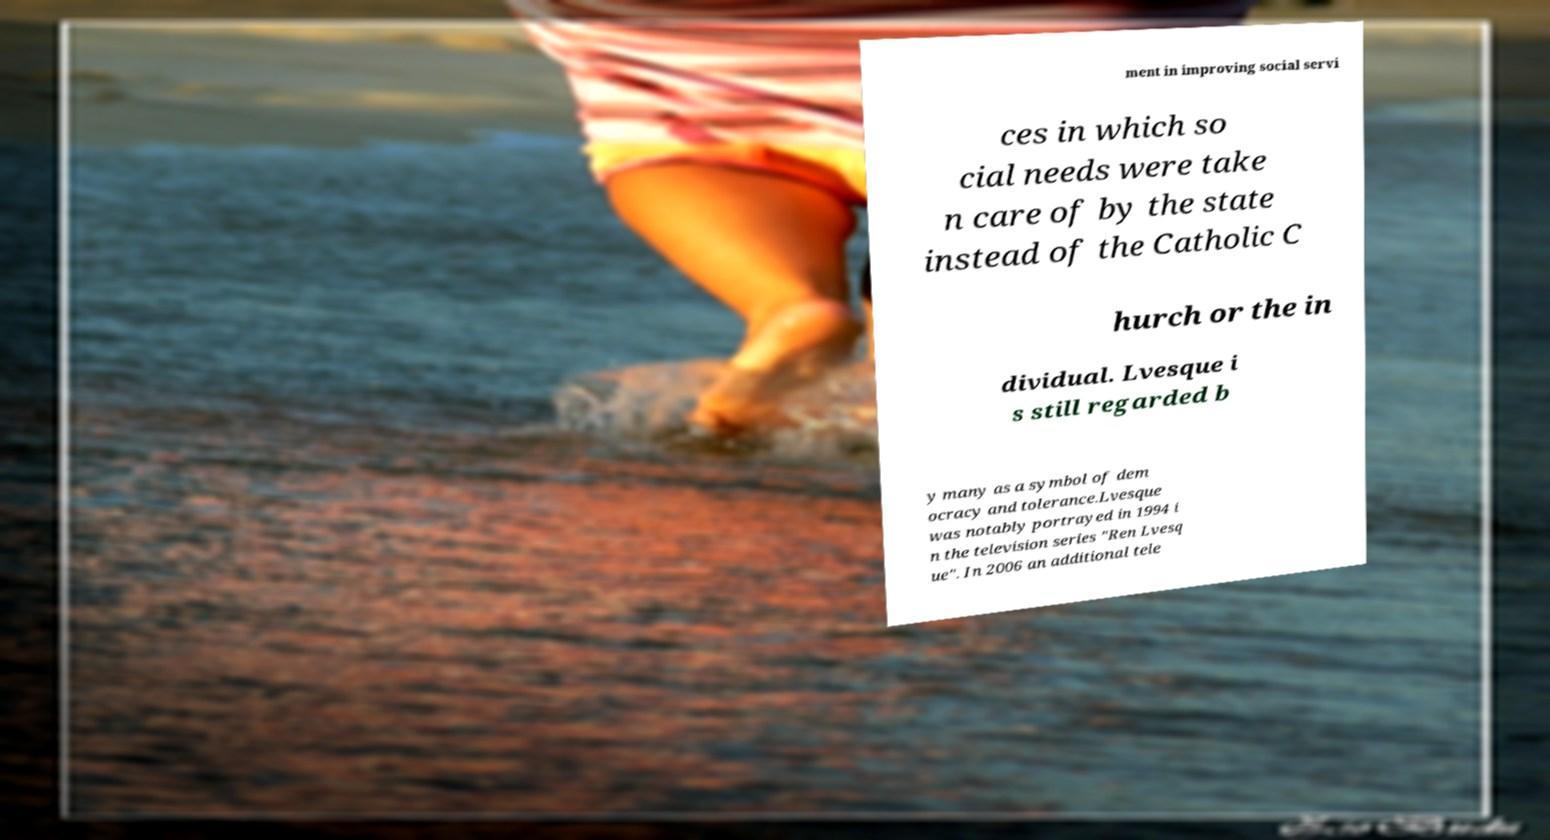Could you extract and type out the text from this image? ment in improving social servi ces in which so cial needs were take n care of by the state instead of the Catholic C hurch or the in dividual. Lvesque i s still regarded b y many as a symbol of dem ocracy and tolerance.Lvesque was notably portrayed in 1994 i n the television series "Ren Lvesq ue". In 2006 an additional tele 